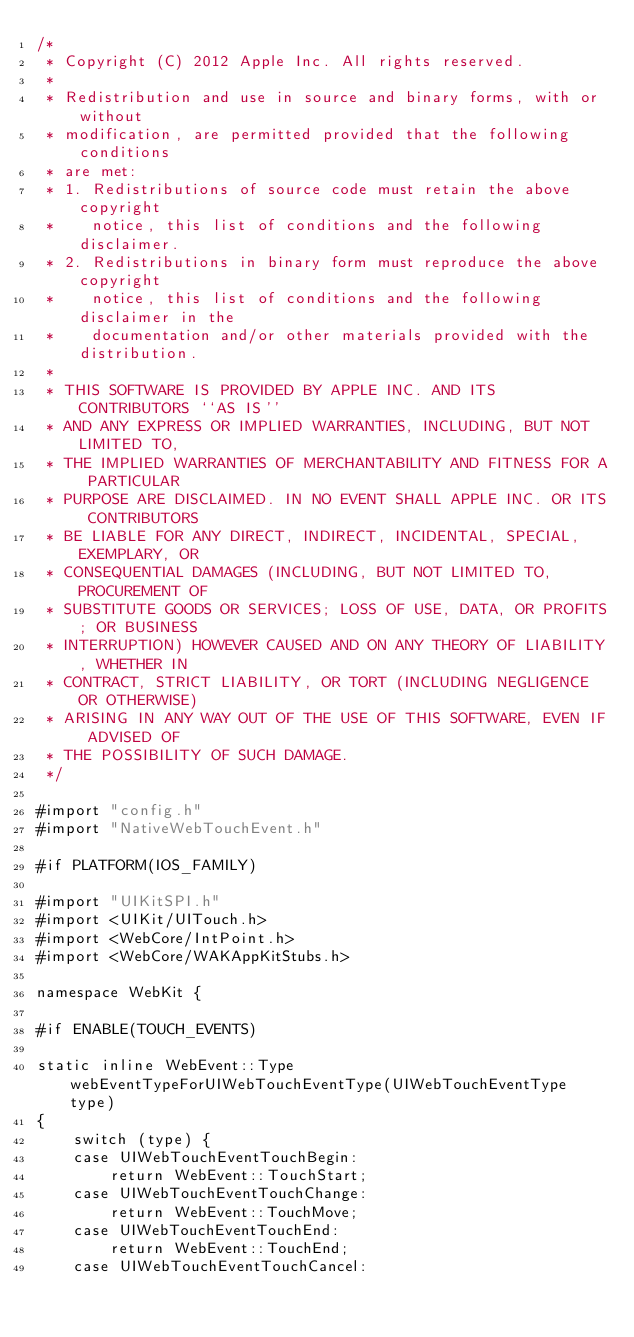<code> <loc_0><loc_0><loc_500><loc_500><_ObjectiveC_>/*
 * Copyright (C) 2012 Apple Inc. All rights reserved.
 *
 * Redistribution and use in source and binary forms, with or without
 * modification, are permitted provided that the following conditions
 * are met:
 * 1. Redistributions of source code must retain the above copyright
 *    notice, this list of conditions and the following disclaimer.
 * 2. Redistributions in binary form must reproduce the above copyright
 *    notice, this list of conditions and the following disclaimer in the
 *    documentation and/or other materials provided with the distribution.
 *
 * THIS SOFTWARE IS PROVIDED BY APPLE INC. AND ITS CONTRIBUTORS ``AS IS''
 * AND ANY EXPRESS OR IMPLIED WARRANTIES, INCLUDING, BUT NOT LIMITED TO,
 * THE IMPLIED WARRANTIES OF MERCHANTABILITY AND FITNESS FOR A PARTICULAR
 * PURPOSE ARE DISCLAIMED. IN NO EVENT SHALL APPLE INC. OR ITS CONTRIBUTORS
 * BE LIABLE FOR ANY DIRECT, INDIRECT, INCIDENTAL, SPECIAL, EXEMPLARY, OR
 * CONSEQUENTIAL DAMAGES (INCLUDING, BUT NOT LIMITED TO, PROCUREMENT OF
 * SUBSTITUTE GOODS OR SERVICES; LOSS OF USE, DATA, OR PROFITS; OR BUSINESS
 * INTERRUPTION) HOWEVER CAUSED AND ON ANY THEORY OF LIABILITY, WHETHER IN
 * CONTRACT, STRICT LIABILITY, OR TORT (INCLUDING NEGLIGENCE OR OTHERWISE)
 * ARISING IN ANY WAY OUT OF THE USE OF THIS SOFTWARE, EVEN IF ADVISED OF
 * THE POSSIBILITY OF SUCH DAMAGE.
 */

#import "config.h"
#import "NativeWebTouchEvent.h"

#if PLATFORM(IOS_FAMILY)

#import "UIKitSPI.h"
#import <UIKit/UITouch.h>
#import <WebCore/IntPoint.h>
#import <WebCore/WAKAppKitStubs.h>

namespace WebKit {

#if ENABLE(TOUCH_EVENTS)

static inline WebEvent::Type webEventTypeForUIWebTouchEventType(UIWebTouchEventType type)
{
    switch (type) {
    case UIWebTouchEventTouchBegin:
        return WebEvent::TouchStart;
    case UIWebTouchEventTouchChange:
        return WebEvent::TouchMove;
    case UIWebTouchEventTouchEnd:
        return WebEvent::TouchEnd;
    case UIWebTouchEventTouchCancel:</code> 